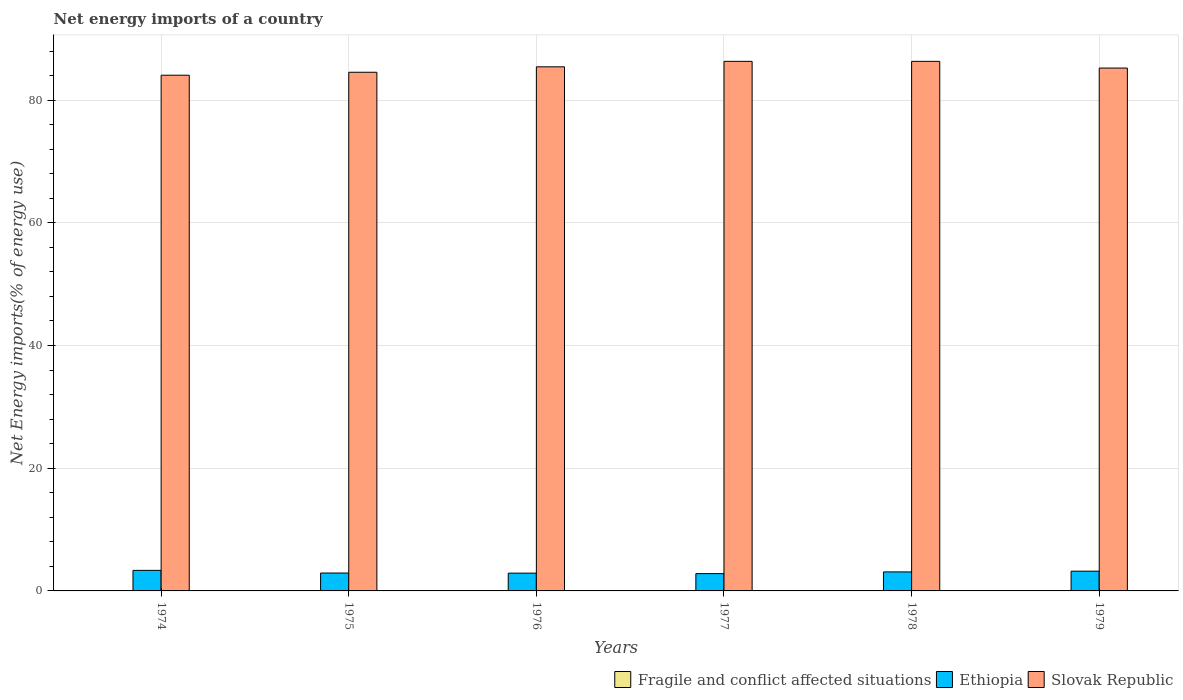Are the number of bars per tick equal to the number of legend labels?
Ensure brevity in your answer.  No. How many bars are there on the 6th tick from the left?
Offer a terse response. 2. How many bars are there on the 5th tick from the right?
Your answer should be very brief. 2. What is the label of the 3rd group of bars from the left?
Give a very brief answer. 1976. What is the net energy imports in Slovak Republic in 1979?
Give a very brief answer. 85.22. Across all years, what is the maximum net energy imports in Slovak Republic?
Give a very brief answer. 86.32. Across all years, what is the minimum net energy imports in Slovak Republic?
Your answer should be very brief. 84.06. In which year was the net energy imports in Ethiopia maximum?
Your response must be concise. 1974. What is the total net energy imports in Fragile and conflict affected situations in the graph?
Give a very brief answer. 0. What is the difference between the net energy imports in Slovak Republic in 1976 and that in 1978?
Offer a terse response. -0.89. What is the difference between the net energy imports in Fragile and conflict affected situations in 1974 and the net energy imports in Slovak Republic in 1978?
Provide a short and direct response. -86.32. What is the average net energy imports in Ethiopia per year?
Offer a very short reply. 3.05. In the year 1978, what is the difference between the net energy imports in Ethiopia and net energy imports in Slovak Republic?
Keep it short and to the point. -83.22. What is the ratio of the net energy imports in Ethiopia in 1976 to that in 1979?
Make the answer very short. 0.9. What is the difference between the highest and the second highest net energy imports in Slovak Republic?
Give a very brief answer. 0. What is the difference between the highest and the lowest net energy imports in Ethiopia?
Make the answer very short. 0.53. Are all the bars in the graph horizontal?
Provide a short and direct response. No. Are the values on the major ticks of Y-axis written in scientific E-notation?
Ensure brevity in your answer.  No. Does the graph contain grids?
Your response must be concise. Yes. Where does the legend appear in the graph?
Make the answer very short. Bottom right. How many legend labels are there?
Give a very brief answer. 3. How are the legend labels stacked?
Provide a succinct answer. Horizontal. What is the title of the graph?
Your answer should be very brief. Net energy imports of a country. Does "Japan" appear as one of the legend labels in the graph?
Provide a short and direct response. No. What is the label or title of the Y-axis?
Your answer should be very brief. Net Energy imports(% of energy use). What is the Net Energy imports(% of energy use) in Fragile and conflict affected situations in 1974?
Offer a very short reply. 0. What is the Net Energy imports(% of energy use) of Ethiopia in 1974?
Your response must be concise. 3.35. What is the Net Energy imports(% of energy use) of Slovak Republic in 1974?
Your answer should be very brief. 84.06. What is the Net Energy imports(% of energy use) in Ethiopia in 1975?
Offer a very short reply. 2.92. What is the Net Energy imports(% of energy use) of Slovak Republic in 1975?
Make the answer very short. 84.54. What is the Net Energy imports(% of energy use) of Ethiopia in 1976?
Offer a very short reply. 2.9. What is the Net Energy imports(% of energy use) in Slovak Republic in 1976?
Give a very brief answer. 85.43. What is the Net Energy imports(% of energy use) of Fragile and conflict affected situations in 1977?
Provide a succinct answer. 0. What is the Net Energy imports(% of energy use) of Ethiopia in 1977?
Give a very brief answer. 2.82. What is the Net Energy imports(% of energy use) in Slovak Republic in 1977?
Your answer should be very brief. 86.32. What is the Net Energy imports(% of energy use) of Fragile and conflict affected situations in 1978?
Give a very brief answer. 0. What is the Net Energy imports(% of energy use) of Ethiopia in 1978?
Your answer should be very brief. 3.1. What is the Net Energy imports(% of energy use) in Slovak Republic in 1978?
Provide a succinct answer. 86.32. What is the Net Energy imports(% of energy use) in Fragile and conflict affected situations in 1979?
Provide a succinct answer. 0. What is the Net Energy imports(% of energy use) in Ethiopia in 1979?
Your response must be concise. 3.22. What is the Net Energy imports(% of energy use) in Slovak Republic in 1979?
Your response must be concise. 85.22. Across all years, what is the maximum Net Energy imports(% of energy use) of Ethiopia?
Offer a terse response. 3.35. Across all years, what is the maximum Net Energy imports(% of energy use) in Slovak Republic?
Your response must be concise. 86.32. Across all years, what is the minimum Net Energy imports(% of energy use) of Ethiopia?
Your answer should be very brief. 2.82. Across all years, what is the minimum Net Energy imports(% of energy use) of Slovak Republic?
Your answer should be very brief. 84.06. What is the total Net Energy imports(% of energy use) of Fragile and conflict affected situations in the graph?
Offer a terse response. 0. What is the total Net Energy imports(% of energy use) in Ethiopia in the graph?
Provide a succinct answer. 18.3. What is the total Net Energy imports(% of energy use) in Slovak Republic in the graph?
Your answer should be compact. 511.88. What is the difference between the Net Energy imports(% of energy use) in Ethiopia in 1974 and that in 1975?
Offer a terse response. 0.43. What is the difference between the Net Energy imports(% of energy use) of Slovak Republic in 1974 and that in 1975?
Offer a terse response. -0.48. What is the difference between the Net Energy imports(% of energy use) in Ethiopia in 1974 and that in 1976?
Provide a short and direct response. 0.45. What is the difference between the Net Energy imports(% of energy use) in Slovak Republic in 1974 and that in 1976?
Ensure brevity in your answer.  -1.37. What is the difference between the Net Energy imports(% of energy use) of Ethiopia in 1974 and that in 1977?
Your response must be concise. 0.53. What is the difference between the Net Energy imports(% of energy use) in Slovak Republic in 1974 and that in 1977?
Provide a short and direct response. -2.26. What is the difference between the Net Energy imports(% of energy use) in Ethiopia in 1974 and that in 1978?
Ensure brevity in your answer.  0.25. What is the difference between the Net Energy imports(% of energy use) of Slovak Republic in 1974 and that in 1978?
Offer a very short reply. -2.26. What is the difference between the Net Energy imports(% of energy use) in Ethiopia in 1974 and that in 1979?
Provide a succinct answer. 0.13. What is the difference between the Net Energy imports(% of energy use) in Slovak Republic in 1974 and that in 1979?
Make the answer very short. -1.17. What is the difference between the Net Energy imports(% of energy use) of Ethiopia in 1975 and that in 1976?
Keep it short and to the point. 0.02. What is the difference between the Net Energy imports(% of energy use) of Slovak Republic in 1975 and that in 1976?
Give a very brief answer. -0.89. What is the difference between the Net Energy imports(% of energy use) in Ethiopia in 1975 and that in 1977?
Offer a very short reply. 0.1. What is the difference between the Net Energy imports(% of energy use) of Slovak Republic in 1975 and that in 1977?
Offer a very short reply. -1.78. What is the difference between the Net Energy imports(% of energy use) of Ethiopia in 1975 and that in 1978?
Provide a succinct answer. -0.18. What is the difference between the Net Energy imports(% of energy use) of Slovak Republic in 1975 and that in 1978?
Your answer should be very brief. -1.78. What is the difference between the Net Energy imports(% of energy use) of Ethiopia in 1975 and that in 1979?
Make the answer very short. -0.3. What is the difference between the Net Energy imports(% of energy use) of Slovak Republic in 1975 and that in 1979?
Your answer should be compact. -0.69. What is the difference between the Net Energy imports(% of energy use) of Ethiopia in 1976 and that in 1977?
Provide a succinct answer. 0.08. What is the difference between the Net Energy imports(% of energy use) in Slovak Republic in 1976 and that in 1977?
Provide a succinct answer. -0.89. What is the difference between the Net Energy imports(% of energy use) of Ethiopia in 1976 and that in 1978?
Your response must be concise. -0.2. What is the difference between the Net Energy imports(% of energy use) in Slovak Republic in 1976 and that in 1978?
Make the answer very short. -0.89. What is the difference between the Net Energy imports(% of energy use) in Ethiopia in 1976 and that in 1979?
Provide a succinct answer. -0.32. What is the difference between the Net Energy imports(% of energy use) of Slovak Republic in 1976 and that in 1979?
Offer a very short reply. 0.2. What is the difference between the Net Energy imports(% of energy use) in Ethiopia in 1977 and that in 1978?
Your answer should be very brief. -0.28. What is the difference between the Net Energy imports(% of energy use) in Ethiopia in 1977 and that in 1979?
Offer a very short reply. -0.4. What is the difference between the Net Energy imports(% of energy use) of Slovak Republic in 1977 and that in 1979?
Offer a very short reply. 1.09. What is the difference between the Net Energy imports(% of energy use) in Ethiopia in 1978 and that in 1979?
Offer a very short reply. -0.12. What is the difference between the Net Energy imports(% of energy use) of Slovak Republic in 1978 and that in 1979?
Your response must be concise. 1.09. What is the difference between the Net Energy imports(% of energy use) in Ethiopia in 1974 and the Net Energy imports(% of energy use) in Slovak Republic in 1975?
Provide a succinct answer. -81.19. What is the difference between the Net Energy imports(% of energy use) in Ethiopia in 1974 and the Net Energy imports(% of energy use) in Slovak Republic in 1976?
Make the answer very short. -82.08. What is the difference between the Net Energy imports(% of energy use) of Ethiopia in 1974 and the Net Energy imports(% of energy use) of Slovak Republic in 1977?
Offer a very short reply. -82.97. What is the difference between the Net Energy imports(% of energy use) in Ethiopia in 1974 and the Net Energy imports(% of energy use) in Slovak Republic in 1978?
Ensure brevity in your answer.  -82.97. What is the difference between the Net Energy imports(% of energy use) of Ethiopia in 1974 and the Net Energy imports(% of energy use) of Slovak Republic in 1979?
Make the answer very short. -81.87. What is the difference between the Net Energy imports(% of energy use) in Ethiopia in 1975 and the Net Energy imports(% of energy use) in Slovak Republic in 1976?
Offer a terse response. -82.51. What is the difference between the Net Energy imports(% of energy use) in Ethiopia in 1975 and the Net Energy imports(% of energy use) in Slovak Republic in 1977?
Make the answer very short. -83.4. What is the difference between the Net Energy imports(% of energy use) of Ethiopia in 1975 and the Net Energy imports(% of energy use) of Slovak Republic in 1978?
Provide a succinct answer. -83.4. What is the difference between the Net Energy imports(% of energy use) in Ethiopia in 1975 and the Net Energy imports(% of energy use) in Slovak Republic in 1979?
Your answer should be compact. -82.31. What is the difference between the Net Energy imports(% of energy use) of Ethiopia in 1976 and the Net Energy imports(% of energy use) of Slovak Republic in 1977?
Your response must be concise. -83.42. What is the difference between the Net Energy imports(% of energy use) of Ethiopia in 1976 and the Net Energy imports(% of energy use) of Slovak Republic in 1978?
Your answer should be compact. -83.42. What is the difference between the Net Energy imports(% of energy use) in Ethiopia in 1976 and the Net Energy imports(% of energy use) in Slovak Republic in 1979?
Keep it short and to the point. -82.33. What is the difference between the Net Energy imports(% of energy use) of Ethiopia in 1977 and the Net Energy imports(% of energy use) of Slovak Republic in 1978?
Give a very brief answer. -83.49. What is the difference between the Net Energy imports(% of energy use) of Ethiopia in 1977 and the Net Energy imports(% of energy use) of Slovak Republic in 1979?
Provide a short and direct response. -82.4. What is the difference between the Net Energy imports(% of energy use) in Ethiopia in 1978 and the Net Energy imports(% of energy use) in Slovak Republic in 1979?
Provide a short and direct response. -82.13. What is the average Net Energy imports(% of energy use) of Ethiopia per year?
Ensure brevity in your answer.  3.05. What is the average Net Energy imports(% of energy use) in Slovak Republic per year?
Keep it short and to the point. 85.31. In the year 1974, what is the difference between the Net Energy imports(% of energy use) of Ethiopia and Net Energy imports(% of energy use) of Slovak Republic?
Offer a very short reply. -80.71. In the year 1975, what is the difference between the Net Energy imports(% of energy use) of Ethiopia and Net Energy imports(% of energy use) of Slovak Republic?
Your answer should be compact. -81.62. In the year 1976, what is the difference between the Net Energy imports(% of energy use) of Ethiopia and Net Energy imports(% of energy use) of Slovak Republic?
Your answer should be very brief. -82.53. In the year 1977, what is the difference between the Net Energy imports(% of energy use) in Ethiopia and Net Energy imports(% of energy use) in Slovak Republic?
Your answer should be compact. -83.49. In the year 1978, what is the difference between the Net Energy imports(% of energy use) in Ethiopia and Net Energy imports(% of energy use) in Slovak Republic?
Make the answer very short. -83.22. In the year 1979, what is the difference between the Net Energy imports(% of energy use) in Ethiopia and Net Energy imports(% of energy use) in Slovak Republic?
Offer a very short reply. -82.01. What is the ratio of the Net Energy imports(% of energy use) of Ethiopia in 1974 to that in 1975?
Give a very brief answer. 1.15. What is the ratio of the Net Energy imports(% of energy use) in Slovak Republic in 1974 to that in 1975?
Your answer should be compact. 0.99. What is the ratio of the Net Energy imports(% of energy use) in Ethiopia in 1974 to that in 1976?
Give a very brief answer. 1.16. What is the ratio of the Net Energy imports(% of energy use) in Slovak Republic in 1974 to that in 1976?
Your answer should be compact. 0.98. What is the ratio of the Net Energy imports(% of energy use) of Ethiopia in 1974 to that in 1977?
Make the answer very short. 1.19. What is the ratio of the Net Energy imports(% of energy use) in Slovak Republic in 1974 to that in 1977?
Your answer should be very brief. 0.97. What is the ratio of the Net Energy imports(% of energy use) of Ethiopia in 1974 to that in 1978?
Your answer should be very brief. 1.08. What is the ratio of the Net Energy imports(% of energy use) of Slovak Republic in 1974 to that in 1978?
Offer a terse response. 0.97. What is the ratio of the Net Energy imports(% of energy use) of Ethiopia in 1974 to that in 1979?
Your answer should be compact. 1.04. What is the ratio of the Net Energy imports(% of energy use) in Slovak Republic in 1974 to that in 1979?
Keep it short and to the point. 0.99. What is the ratio of the Net Energy imports(% of energy use) of Ethiopia in 1975 to that in 1976?
Keep it short and to the point. 1.01. What is the ratio of the Net Energy imports(% of energy use) in Slovak Republic in 1975 to that in 1976?
Your answer should be very brief. 0.99. What is the ratio of the Net Energy imports(% of energy use) in Ethiopia in 1975 to that in 1977?
Offer a terse response. 1.03. What is the ratio of the Net Energy imports(% of energy use) of Slovak Republic in 1975 to that in 1977?
Provide a short and direct response. 0.98. What is the ratio of the Net Energy imports(% of energy use) in Ethiopia in 1975 to that in 1978?
Your answer should be very brief. 0.94. What is the ratio of the Net Energy imports(% of energy use) of Slovak Republic in 1975 to that in 1978?
Your answer should be very brief. 0.98. What is the ratio of the Net Energy imports(% of energy use) of Ethiopia in 1975 to that in 1979?
Your answer should be compact. 0.91. What is the ratio of the Net Energy imports(% of energy use) in Ethiopia in 1976 to that in 1977?
Keep it short and to the point. 1.03. What is the ratio of the Net Energy imports(% of energy use) of Slovak Republic in 1976 to that in 1977?
Offer a very short reply. 0.99. What is the ratio of the Net Energy imports(% of energy use) of Ethiopia in 1976 to that in 1978?
Your answer should be very brief. 0.94. What is the ratio of the Net Energy imports(% of energy use) of Ethiopia in 1976 to that in 1979?
Provide a short and direct response. 0.9. What is the ratio of the Net Energy imports(% of energy use) in Ethiopia in 1977 to that in 1978?
Give a very brief answer. 0.91. What is the ratio of the Net Energy imports(% of energy use) in Slovak Republic in 1977 to that in 1978?
Offer a very short reply. 1. What is the ratio of the Net Energy imports(% of energy use) of Ethiopia in 1977 to that in 1979?
Provide a short and direct response. 0.88. What is the ratio of the Net Energy imports(% of energy use) in Slovak Republic in 1977 to that in 1979?
Your response must be concise. 1.01. What is the ratio of the Net Energy imports(% of energy use) of Slovak Republic in 1978 to that in 1979?
Offer a terse response. 1.01. What is the difference between the highest and the second highest Net Energy imports(% of energy use) in Ethiopia?
Ensure brevity in your answer.  0.13. What is the difference between the highest and the lowest Net Energy imports(% of energy use) of Ethiopia?
Make the answer very short. 0.53. What is the difference between the highest and the lowest Net Energy imports(% of energy use) in Slovak Republic?
Offer a terse response. 2.26. 